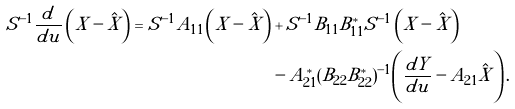<formula> <loc_0><loc_0><loc_500><loc_500>S ^ { - 1 } \frac { d } { d u } \left ( \tilde { X } - \hat { X } \right ) = S ^ { - 1 } A _ { 1 1 } \left ( \tilde { X } - \hat { X } \right ) & + S ^ { - 1 } B _ { 1 1 } B _ { 1 1 } ^ { * } S ^ { - 1 } \left ( \tilde { X } - \hat { X } \right ) \\ & - A _ { 2 1 } ^ { * } ( B _ { 2 2 } B _ { 2 2 } ^ { * } ) ^ { - 1 } \left ( \frac { d Y } { d u } - A _ { 2 1 } \hat { X } \right ) .</formula> 